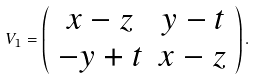<formula> <loc_0><loc_0><loc_500><loc_500>V _ { 1 } = \left ( \begin{array} { c c } x - z & y - t \\ - y + t & x - z \\ \end{array} \right ) .</formula> 